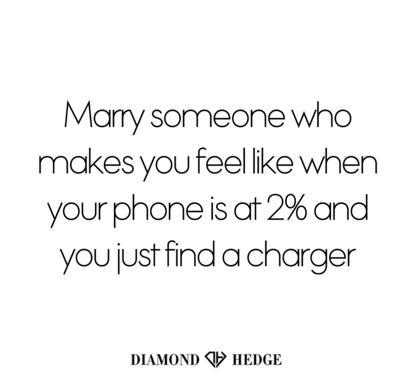What does the quote on the image mean? The quote, 'Marry someone who makes you feel like when your phone is at 2% and you just find a charger,' cleverly uses the situation of a low phone battery and the relief of finding a charger to describe the ideal qualities of a life partner. It suggests looking for a partner who brings immense relief and a sense of security in critical times, much like the essential boost you receive when you're able to recharge your dying phone. This metaphor extends further to imply that a partner should be someone who not only supports you in times of need but energizes you consistently, ensuring you never feel too depleted. 